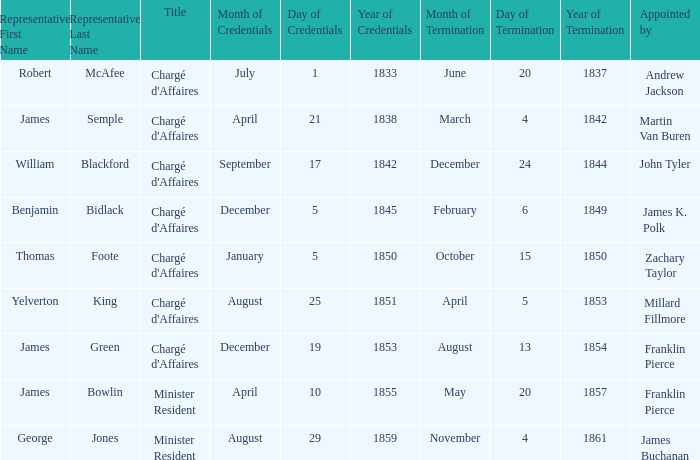What Title has a Termination of Mission of November 4, 1861? Minister Resident. 